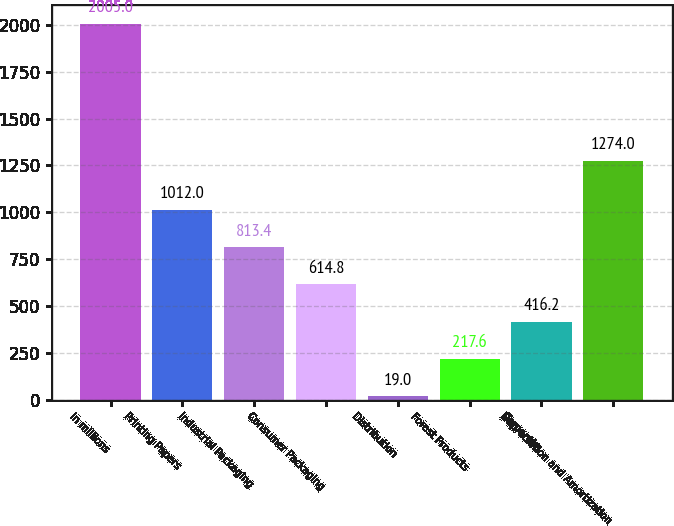<chart> <loc_0><loc_0><loc_500><loc_500><bar_chart><fcel>In millions<fcel>Printing Papers<fcel>Industrial Packaging<fcel>Consumer Packaging<fcel>Distribution<fcel>Forest Products<fcel>Corporate<fcel>Depreciation and Amortization<nl><fcel>2005<fcel>1012<fcel>813.4<fcel>614.8<fcel>19<fcel>217.6<fcel>416.2<fcel>1274<nl></chart> 